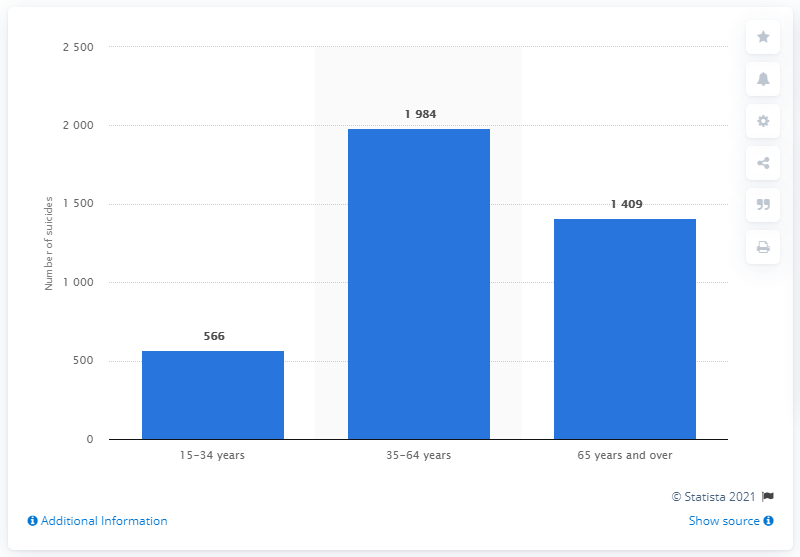Outline some significant characteristics in this image. In 2017, a total of 566 people committed suicide in Italy. 